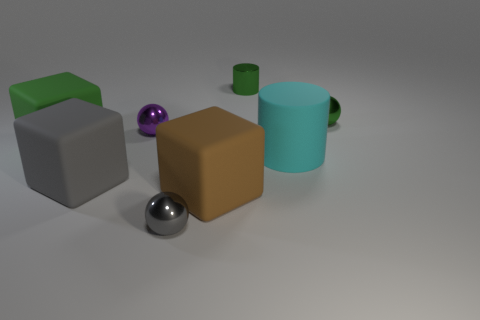Add 1 big brown shiny cylinders. How many objects exist? 9 Add 3 purple shiny things. How many purple shiny things exist? 4 Subtract all green balls. How many balls are left? 2 Subtract all big gray matte cubes. How many cubes are left? 2 Subtract 1 purple balls. How many objects are left? 7 Subtract all balls. How many objects are left? 5 Subtract 1 blocks. How many blocks are left? 2 Subtract all cyan cylinders. Subtract all purple spheres. How many cylinders are left? 1 Subtract all blue spheres. How many gray blocks are left? 1 Subtract all purple metal spheres. Subtract all large green matte things. How many objects are left? 6 